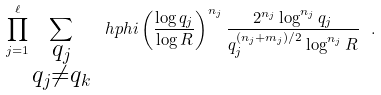<formula> <loc_0><loc_0><loc_500><loc_500>\prod _ { j = 1 } ^ { \ell } \sum _ { \substack { q _ { j } \\ q _ { j } \neq q _ { k } } } \ h p h i \left ( \frac { \log q _ { j } } { \log R } \right ) ^ { n _ { j } } \frac { 2 ^ { n _ { j } } \log ^ { n _ { j } } q _ { j } } { q _ { j } ^ { ( n _ { j } + m _ { j } ) / 2 } \log ^ { n _ { j } } R } \ .</formula> 